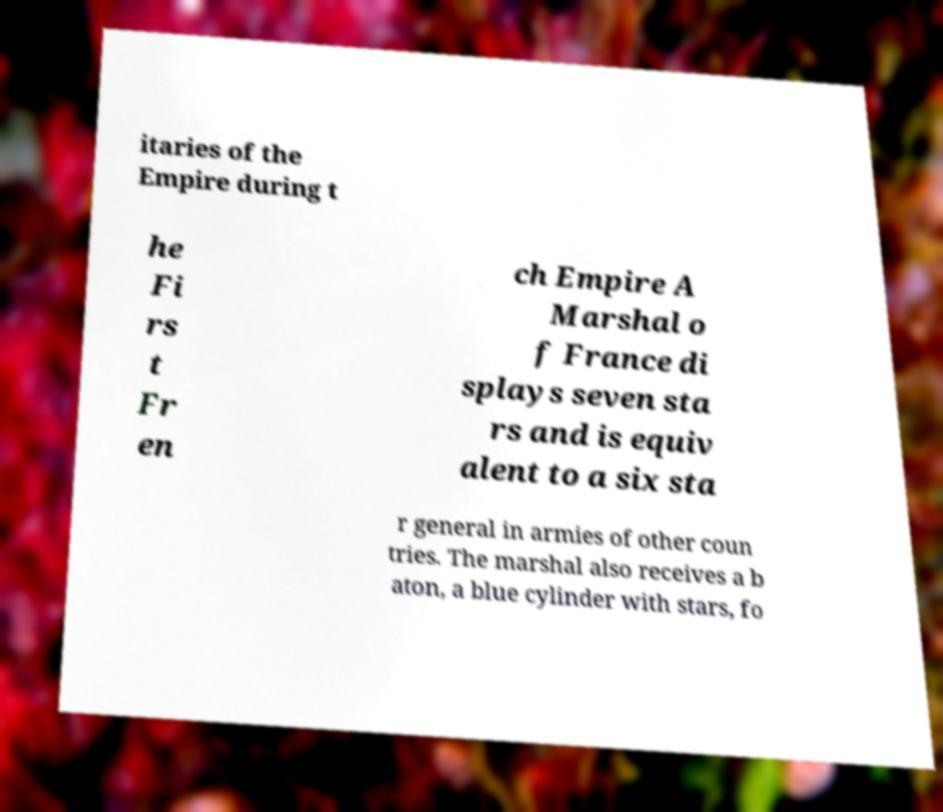For documentation purposes, I need the text within this image transcribed. Could you provide that? itaries of the Empire during t he Fi rs t Fr en ch Empire A Marshal o f France di splays seven sta rs and is equiv alent to a six sta r general in armies of other coun tries. The marshal also receives a b aton, a blue cylinder with stars, fo 